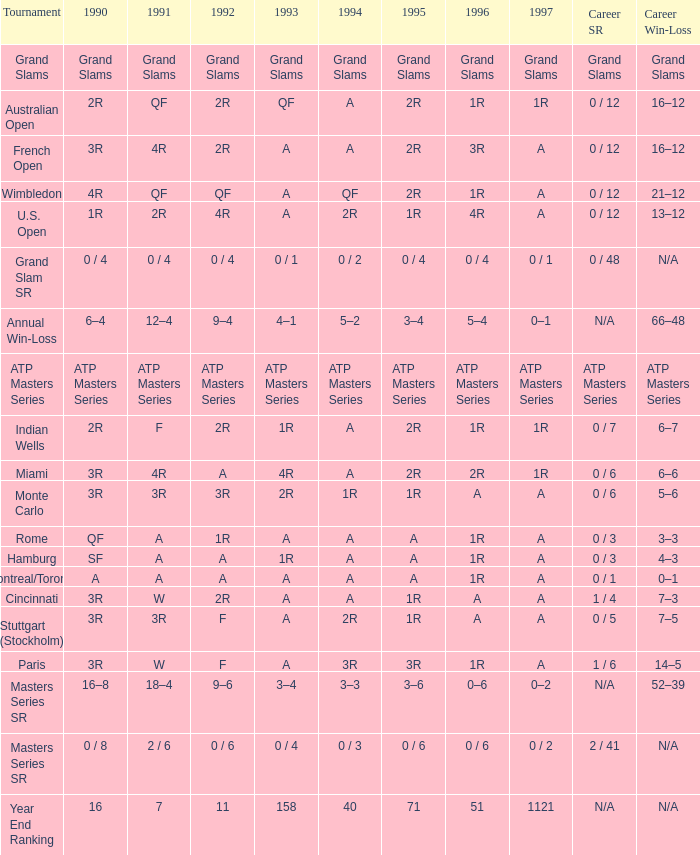What is 1997, when 1996 is "1R", when 1990 is "2R", and when 1991 is "F"? 1R. 